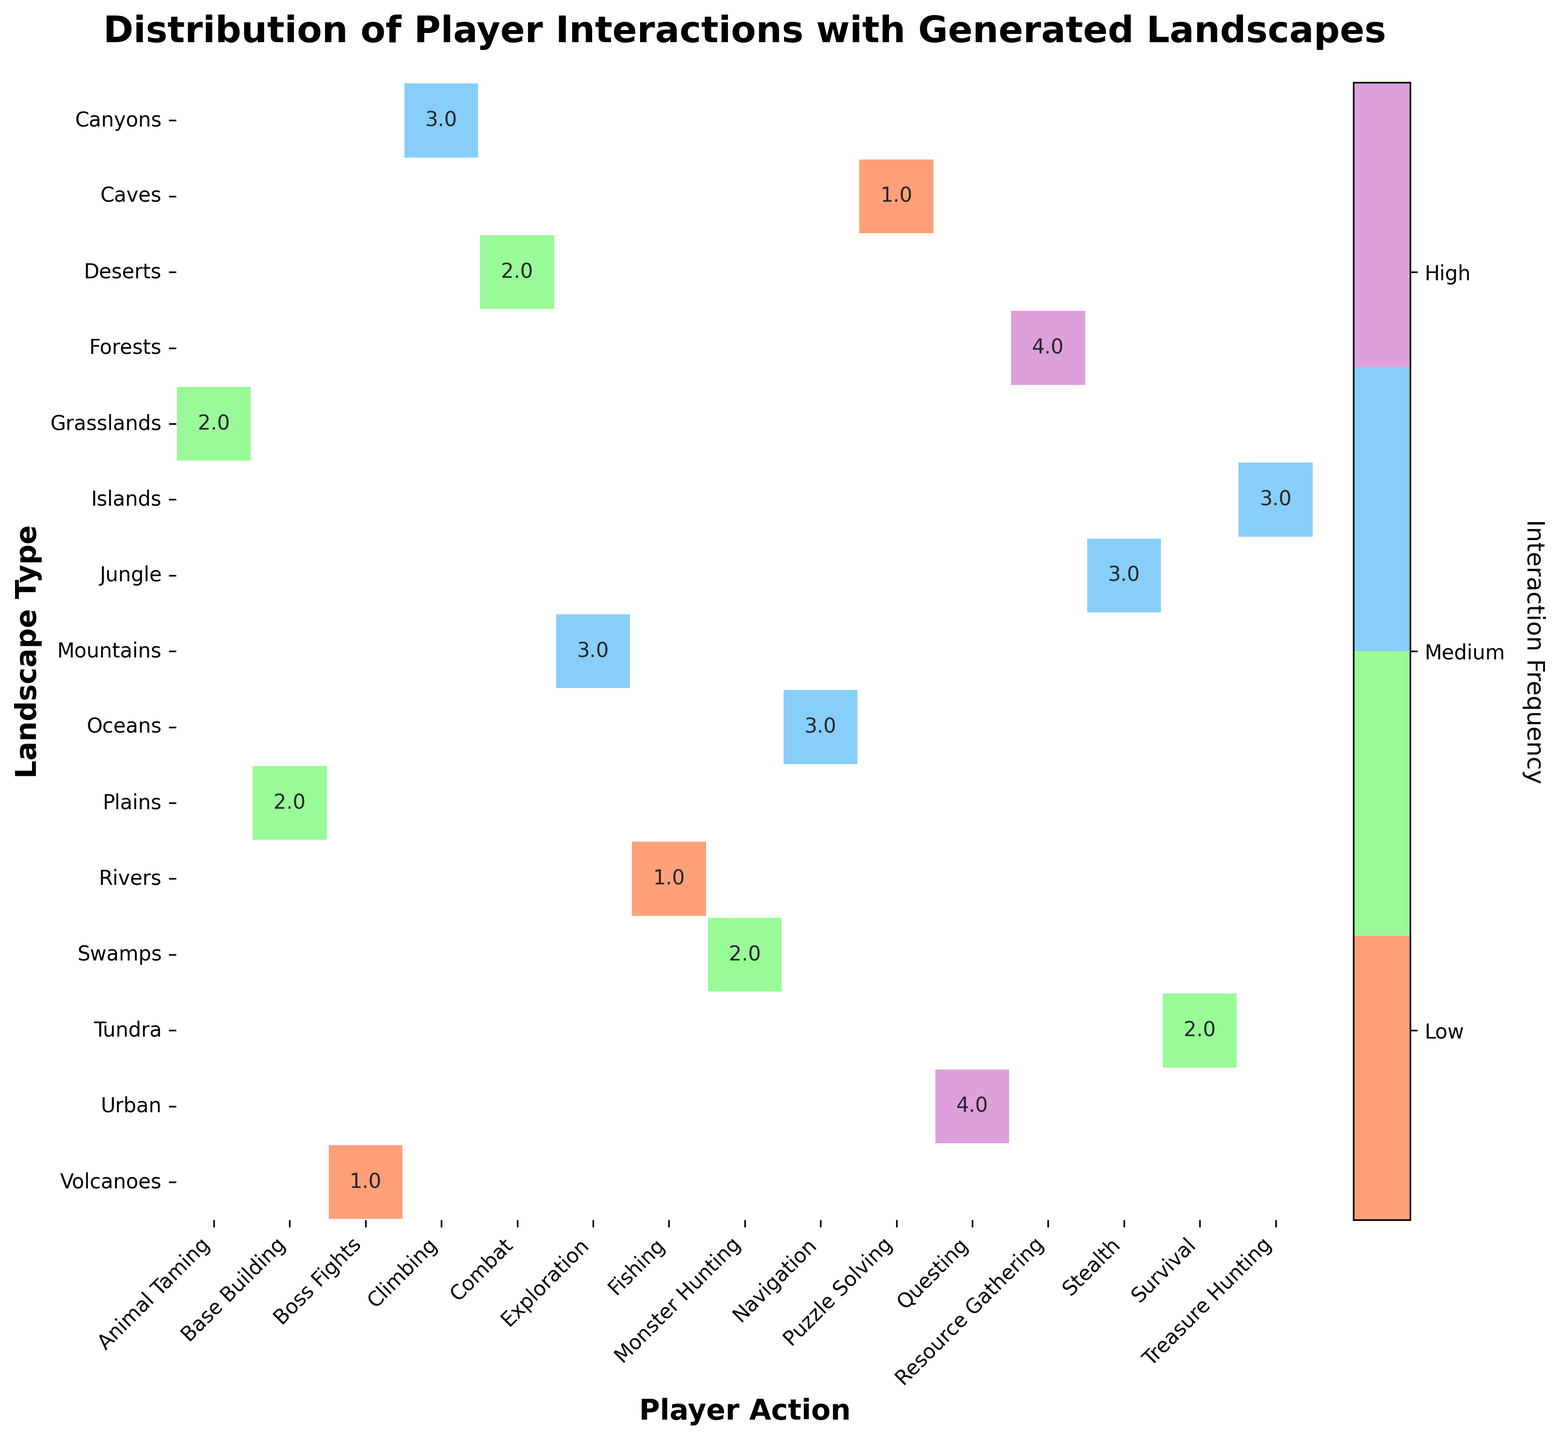What is the title of the mosaic plot? The title of the plot is located at the top and is usually the largest text on the figure.
Answer: Distribution of Player Interactions with Generated Landscapes Which landscape type has the highest frequency of resource gathering? Locate the "Resource Gathering" column and find the cell with the highest numeric value. The cell is mapped to "Very High" for Forests.
Answer: Forests How many landscape types have a "High" frequency of player interactions associated with them? Count the number of cells in the mosaic plot that contain the value corresponding to "High". There are 6 such cells.
Answer: 6 Which game title has an associated landscape with a "Low" frequency of player interactions? Look for cells labeled as "Low" within the mosaic plot and identify the respective game titles. There are three such cells.
Answer: No Man's Sky, Red Dead Redemption 2, Shadow of the Colossus Does the plot show more landscapes with "Medium" or "High" interaction frequency? Count the number of cells corresponding to "Medium" and "High" frequencies. There are 5 "Medium" cells and 6 "High" cells.
Answer: High What landscape type and player action combination has the least interaction frequency? Identify the cells labeled with the smallest values, representing "Low", and note the corresponding landscape types and player actions. One example is "Caves" and "Puzzle Solving".
Answer: Caves and Puzzle Solving Which landscape type is associated with the highest interaction frequency for questing? Find the column labeled "Questing" and locate the cell with the highest numeric value, corresponding to "Very High". The associated landscape type is "Urban".
Answer: Urban Is there any landscape type with a "Medium" frequency in more than one player action? Check for any landscape types that appear in multiple cells with the value corresponding to "Medium". "Plains" (Resource Gathering, Base Building, Animal Taming) and "Swamps" (Monster Hunting, Survival) each has multiple "Medium" values.
Answer: Yes How does the interaction frequency for exploration in mountains compare to that for climbing in canyons? Compare the values in the "Exploration" column for "Mountains" and the "Climbing" column for "Canyons". Both have "High" values.
Answer: They are the same What is the frequency of treasure hunting on islands? Locate the intersection cell of "Islands" in the "Landscape Type" column and "Treasure Hunting" in the "Player Action" column. The value is "High".
Answer: High 